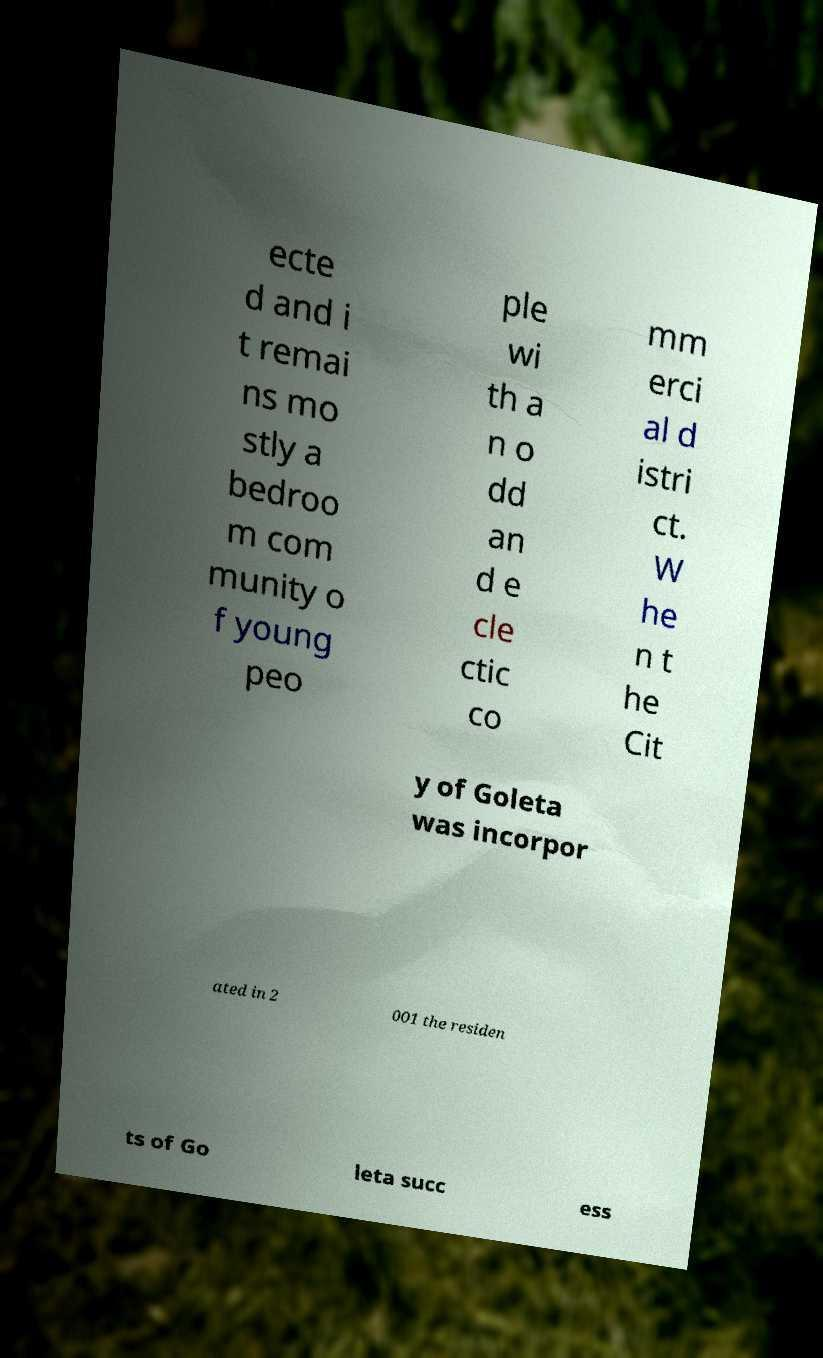There's text embedded in this image that I need extracted. Can you transcribe it verbatim? ecte d and i t remai ns mo stly a bedroo m com munity o f young peo ple wi th a n o dd an d e cle ctic co mm erci al d istri ct. W he n t he Cit y of Goleta was incorpor ated in 2 001 the residen ts of Go leta succ ess 